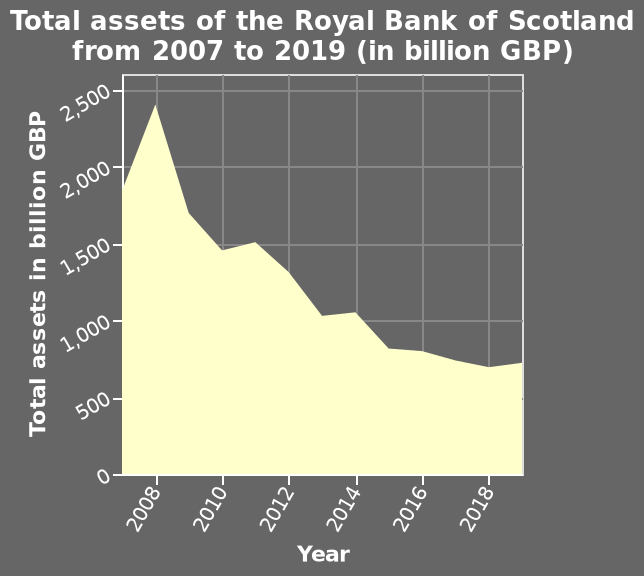<image>
What is the scale of the y-axis? The y-axis has a linear scale ranging from 0 to 2,500 billion GBP. What is the name of the area chart?  The area chart is named "Total assets of the Royal Bank of Scotland". What is the highest total assets of The Royal Bank of Scotland?  The highest total assets of The Royal Bank of Scotland is around 2375 billion GBP. 